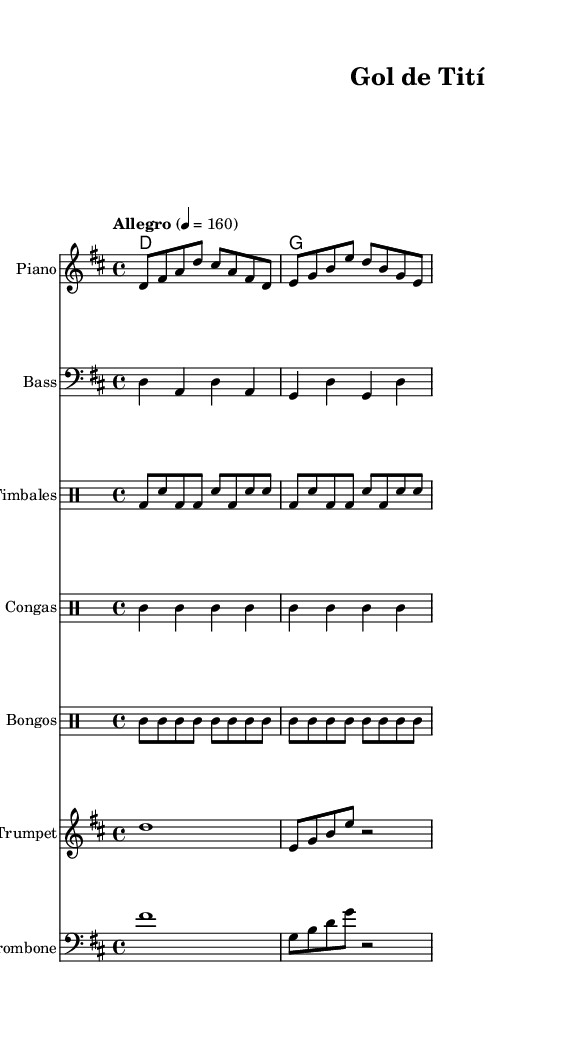What is the key signature of this music? The key signature is D major, which has two sharps (F# and C#). This can be determined by examining the key signature at the beginning of the score.
Answer: D major What is the time signature of the piece? The time signature is 4/4, indicated at the beginning of the score. It shows that there are four beats in a measure and a quarter note receives one beat.
Answer: 4/4 What is the tempo marking for this piece? The tempo marking is "Allegro" at a quarter note equal to 160, which indicates a fast-paced tempo. This is found written above the staff at the beginning of the score.
Answer: Allegro 4 = 160 How many instruments are indicated in this score? There are six instruments indicated in the score: Piano, Bass, Timbales, Congas, Bongos, Trumpet, and Trombone. The instrument names are listed at the start of each staff.
Answer: Six What is the first note of the melody? The first note of the melody is D. This can be identified as the melody starts with the note D in the provided musical staff.
Answer: D What type of music is this piece classified as? This piece is classified as Salsa, which is a Latin music genre known for its energetic rhythms and lively dance style. The instrumentation and rhythmic patterns in the score align with Salsa music characteristics.
Answer: Salsa What rhythmic pattern is played by the Timbales? The Timbales play a pattern consisting of a bass drum and snare alternation, which can be seen in the notated drum part focusing on the kick drum and snare hits.
Answer: Bass and snare alternation 